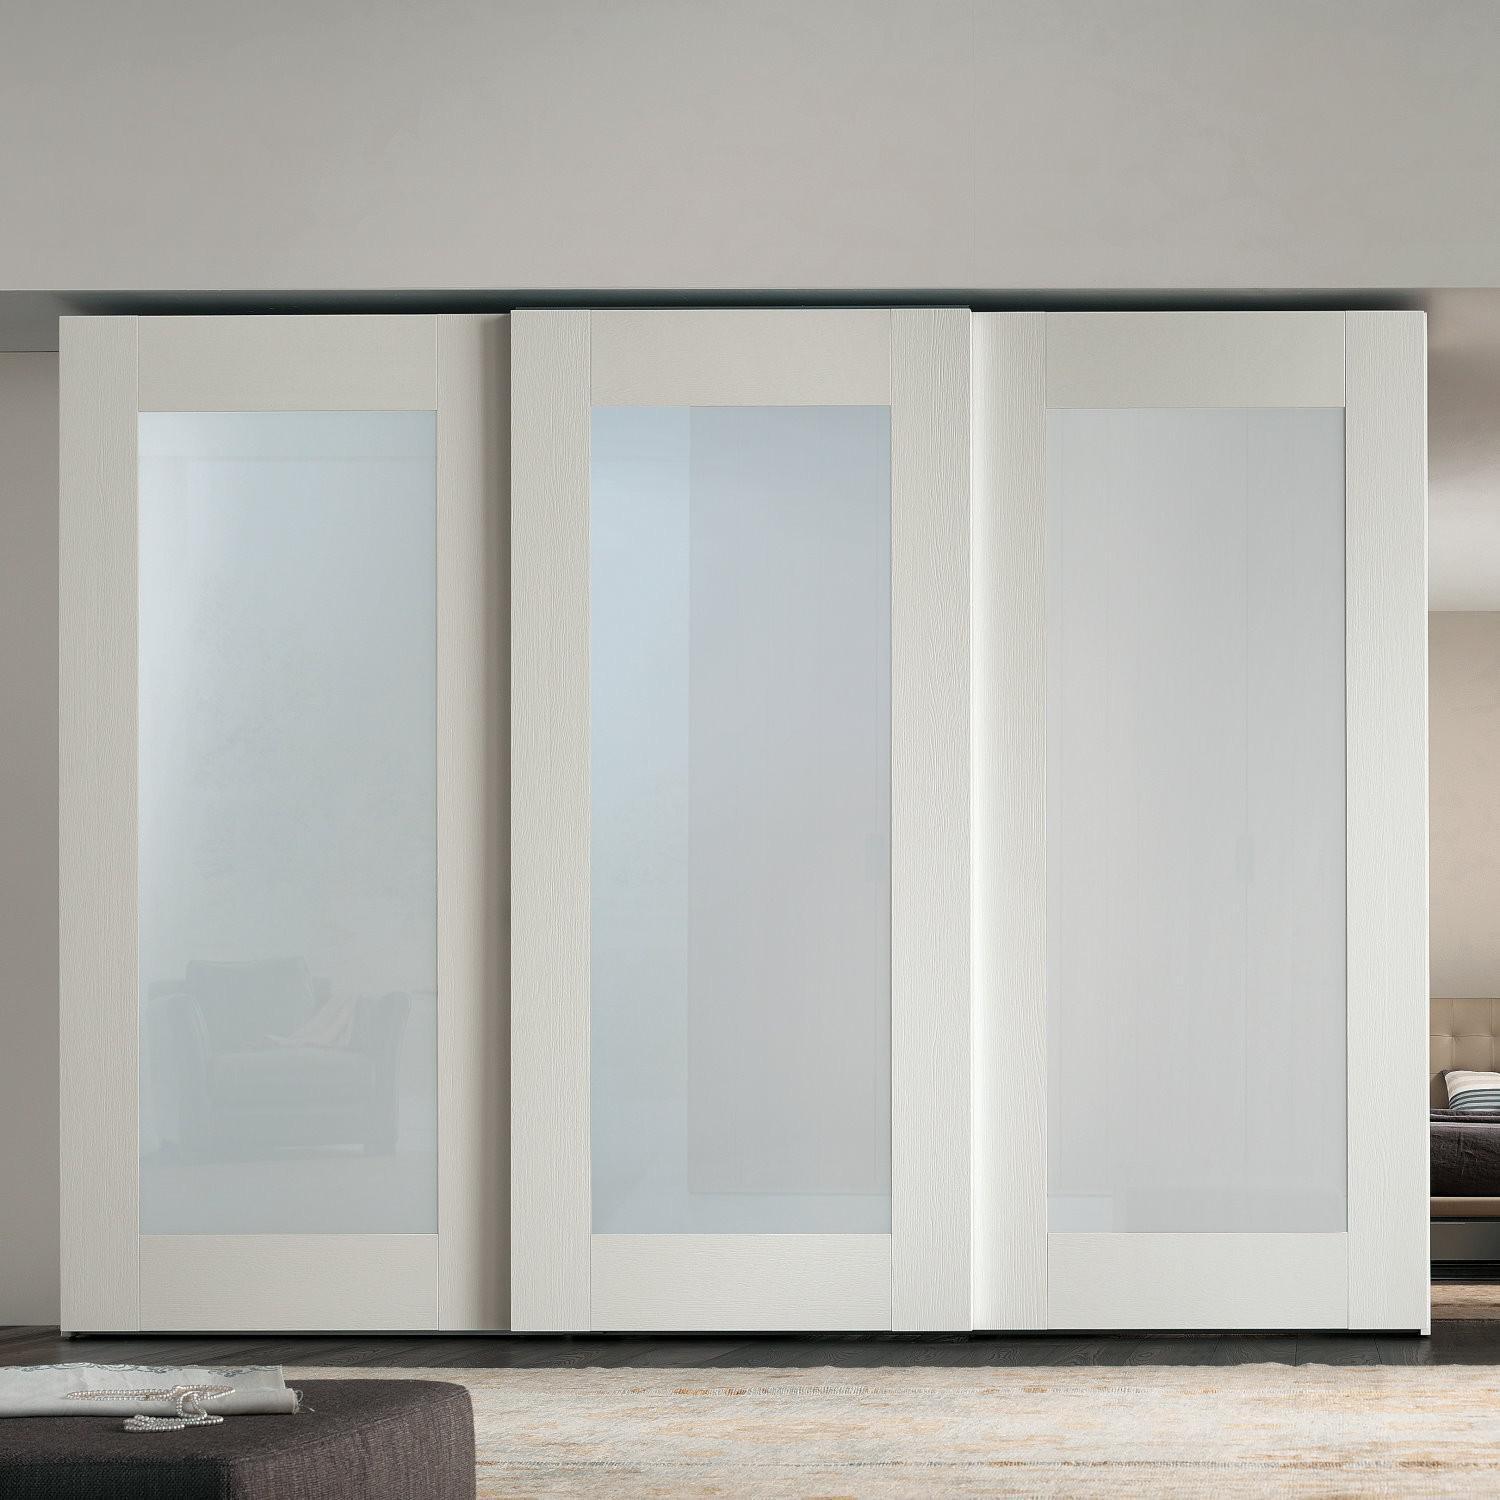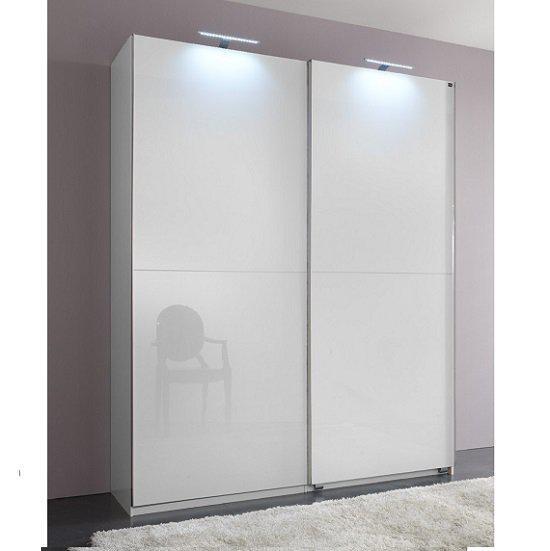The first image is the image on the left, the second image is the image on the right. Assess this claim about the two images: "A free standing white cabinet with two closed doors is placed in front of a wall.". Correct or not? Answer yes or no. Yes. The first image is the image on the left, the second image is the image on the right. Assess this claim about the two images: "An image shows a two door dimensional unit with a white front.". Correct or not? Answer yes or no. Yes. 